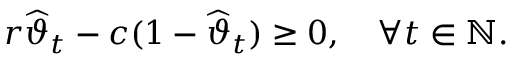<formula> <loc_0><loc_0><loc_500><loc_500>r \widehat { \vartheta } _ { t } - c ( 1 - \widehat { \vartheta } _ { t } ) \geq 0 , \quad \forall t \in \mathbb { N } .</formula> 